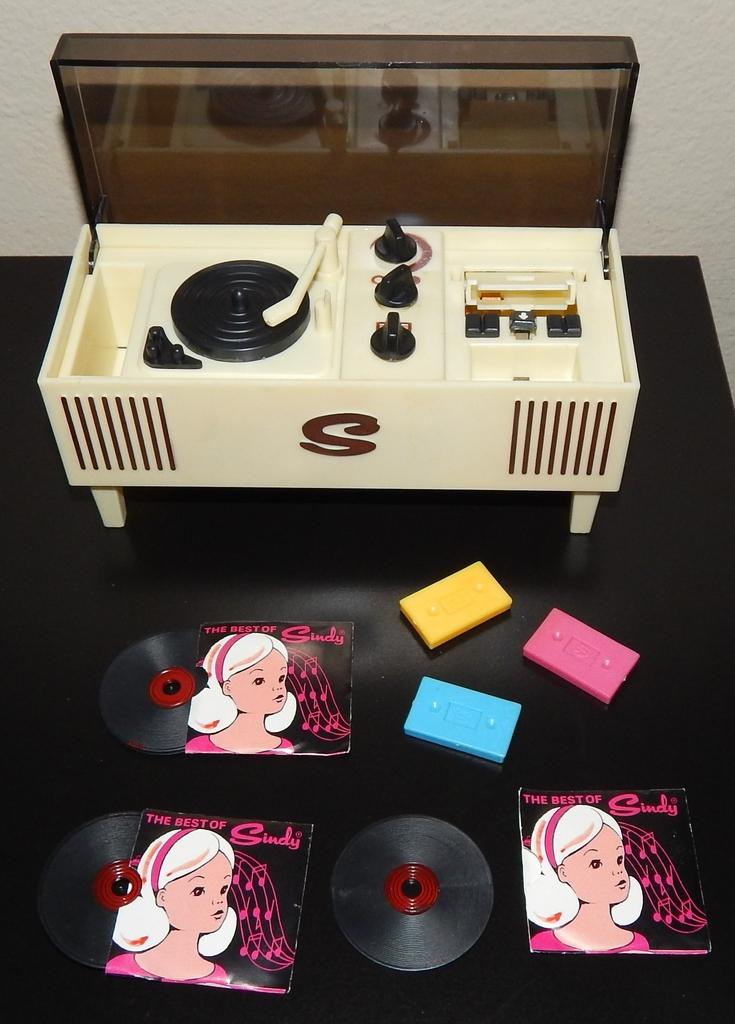Provide a one-sentence caption for the provided image. A child's record player has a large S on the front. 